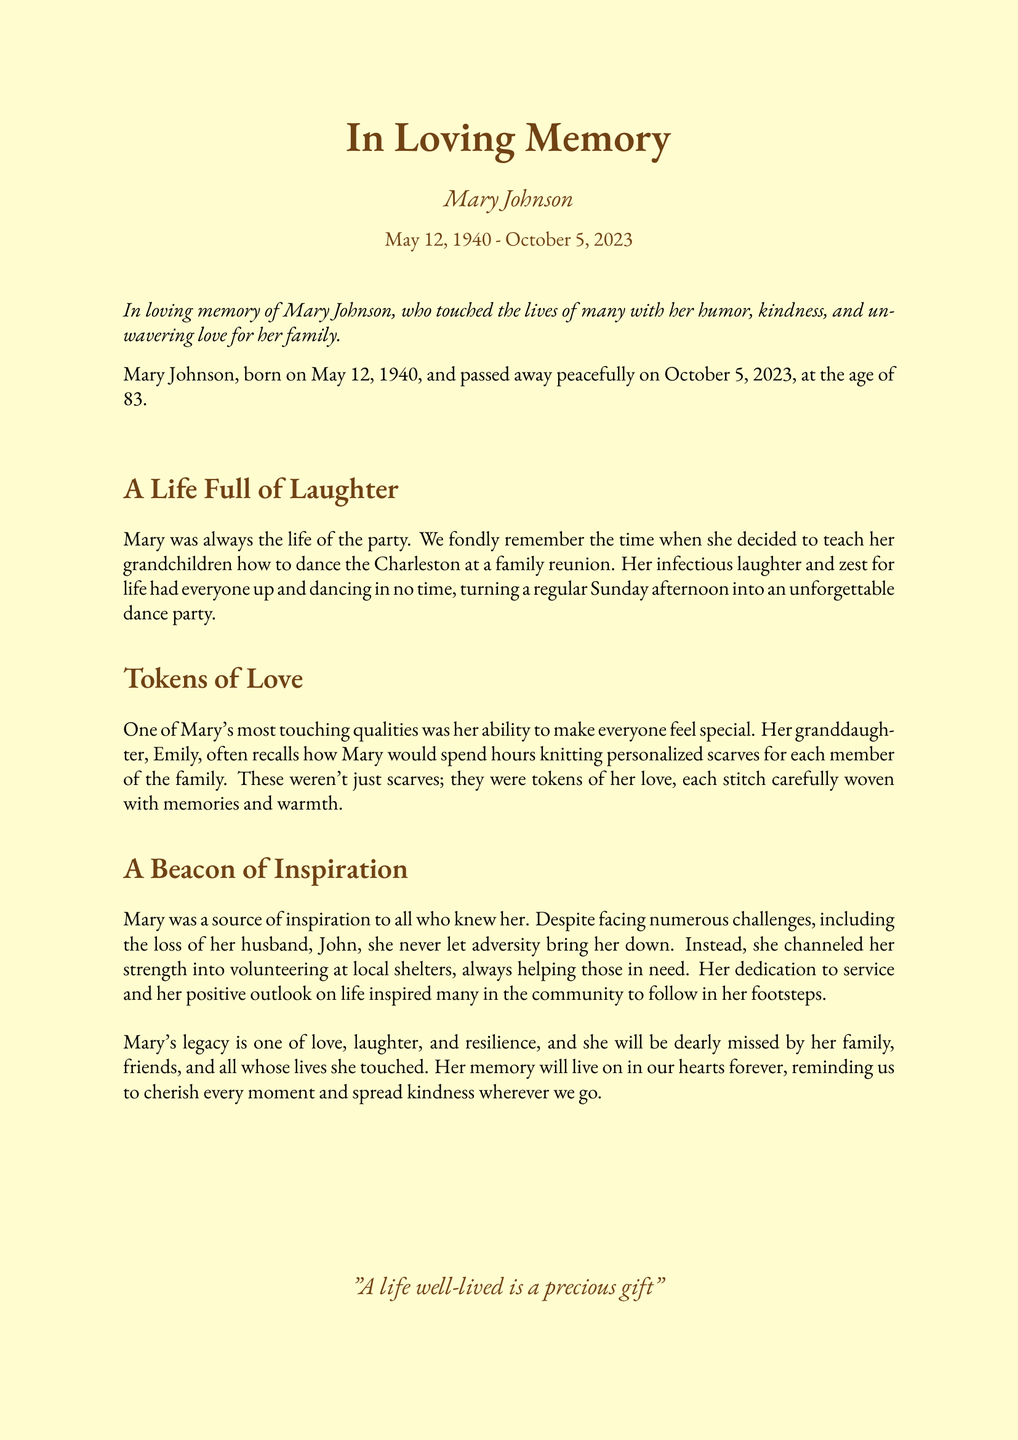What is the full name of the deceased? The document states the full name of the deceased as Mary Johnson.
Answer: Mary Johnson What is the date of passing? The obituary mentions the date of passing as October 5, 2023.
Answer: October 5, 2023 How old was Mary Johnson when she passed away? The document indicates that Mary Johnson was 83 years old at the time of her passing.
Answer: 83 What was one of Mary's most touching qualities? The document mentions her ability to make everyone feel special as one of her most touching qualities.
Answer: Ability to make everyone feel special What activity did Mary teach her grandchildren at the family reunion? The document states that Mary decided to teach her grandchildren how to dance the Charleston.
Answer: Dance the Charleston What did Mary do after facing numerous challenges, including the loss of her husband? The document highlights that Mary channeled her strength into volunteering at local shelters.
Answer: Volunteering at local shelters What was the primary theme expressed in Mary's legacy? The document reflects that Mary's legacy is one of love, laughter, and resilience.
Answer: Love, laughter, and resilience What memorable item did Mary knit for her family? The obituary notes that Mary would knit personalized scarves for each family member.
Answer: Personalized scarves 